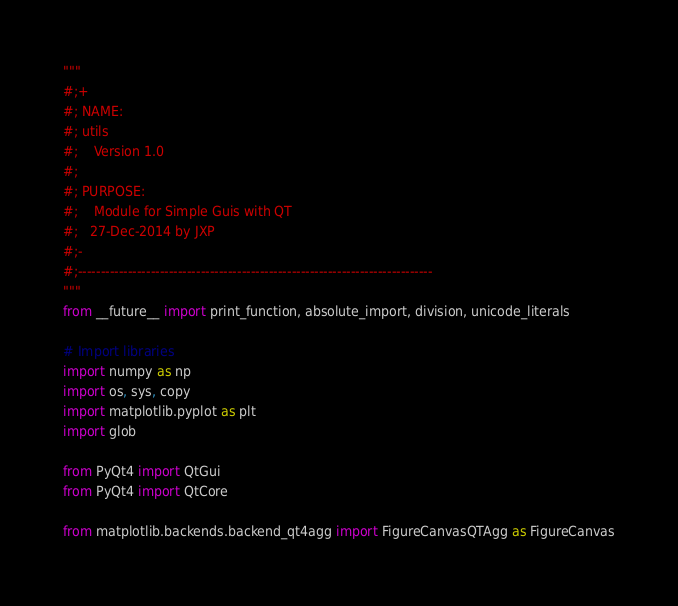Convert code to text. <code><loc_0><loc_0><loc_500><loc_500><_Python_>"""
#;+ 
#; NAME:
#; utils
#;    Version 1.0
#;
#; PURPOSE:
#;    Module for Simple Guis with QT
#;   27-Dec-2014 by JXP
#;-
#;------------------------------------------------------------------------------
"""
from __future__ import print_function, absolute_import, division, unicode_literals

# Import libraries
import numpy as np
import os, sys, copy
import matplotlib.pyplot as plt
import glob

from PyQt4 import QtGui
from PyQt4 import QtCore

from matplotlib.backends.backend_qt4agg import FigureCanvasQTAgg as FigureCanvas</code> 